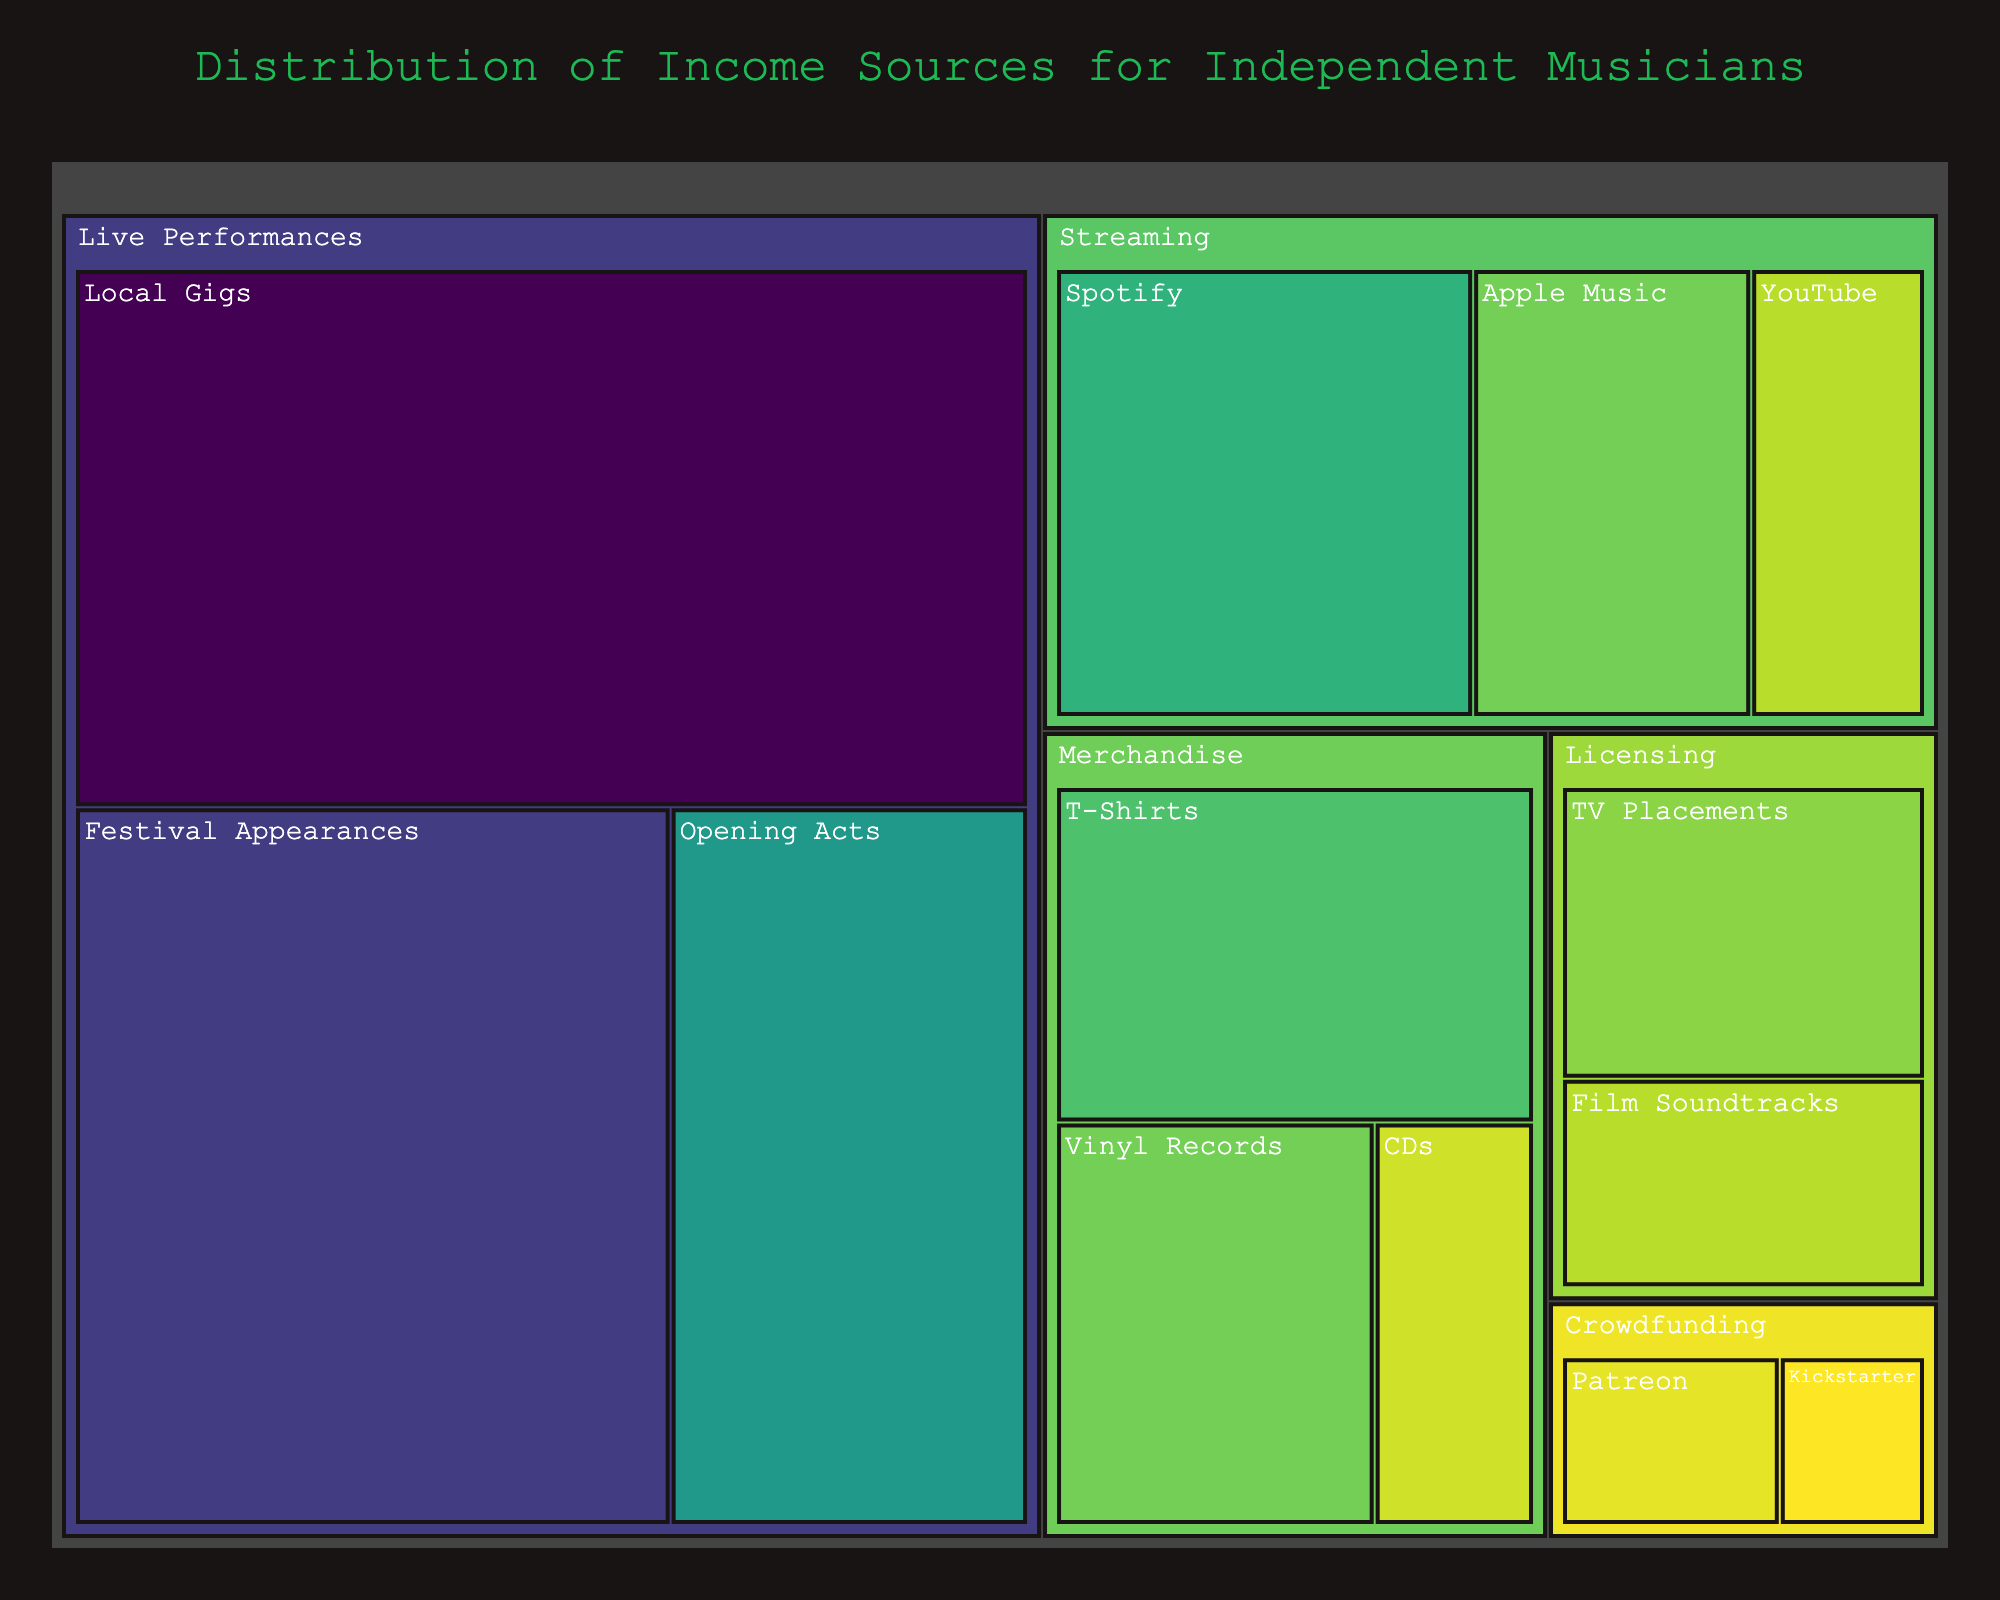What's the title of the figure? The title of the figure is usually located at the top. It helps the viewer understand the main subject being depicted. Here, the title reads "Distribution of Income Sources for Independent Musicians".
Answer: Distribution of Income Sources for Independent Musicians Which category contributes the most to the income of independent musicians? The largest section of the treemap represents the category with the highest contribution. In this case, "Live Performances" has the largest area occupied.
Answer: Live Performances What subcategory within Live Performances has the highest value? Within Live Performances, the largest sub-rectangle will have the highest value. Here, "Local Gigs" is the largest subcategory.
Answer: Local Gigs What percentage of income comes from Spotify streaming? Look at the area labeled "Spotify" under the category "Streaming". The hover data will reveal the value, which is 12%.
Answer: 12% Compare the income from T-Shirts sales to Vinyl Records sales. Which is higher? Find the areas labeled "T-Shirts" and "Vinyl Records" under the "Merchandise" category. "T-Shirts" has a value of 10, while "Vinyl Records" is 8. T-Shirts are higher.
Answer: T-Shirts Calculate the total income from Crowdfunding sources. Sum the values of the subcategories under "Crowdfunding". Patreon is 3 and Kickstarter is 2. So, 3 + 2 = 5.
Answer: 5 Which has a higher value, Apple Music streaming or Film Soundtracks licensing? Compare the areas labeled "Apple Music" under "Streaming" and "Film Soundtracks" under "Licensing". Apple Music has a value of 8, while Film Soundtracks has 5. Apple Music is higher.
Answer: Apple Music What is the combined value of all streaming sources? Sum the values of the subcategories under "Streaming". Spotify is 12, Apple Music is 8, and YouTube is 5. So, 12 + 8 + 5 = 25.
Answer: 25 How does the combined income from Licensing compare to live performances from Festival Appearances? Sum the values of the subcategories under "Licensing" and compare it to the value of "Festival Appearances" under "Live Performances". Licensing is 7 + 5 = 12. Festival Appearances is 25. Festival Appearances are higher.
Answer: Festival Appearances Which subcategory under Live Performances has the second-highest value? Within "Live Performances", find the second-largest sub-rectangle. The largest is "Local Gigs" (30), followed by "Festival Appearances" (25).
Answer: Festival Appearances 